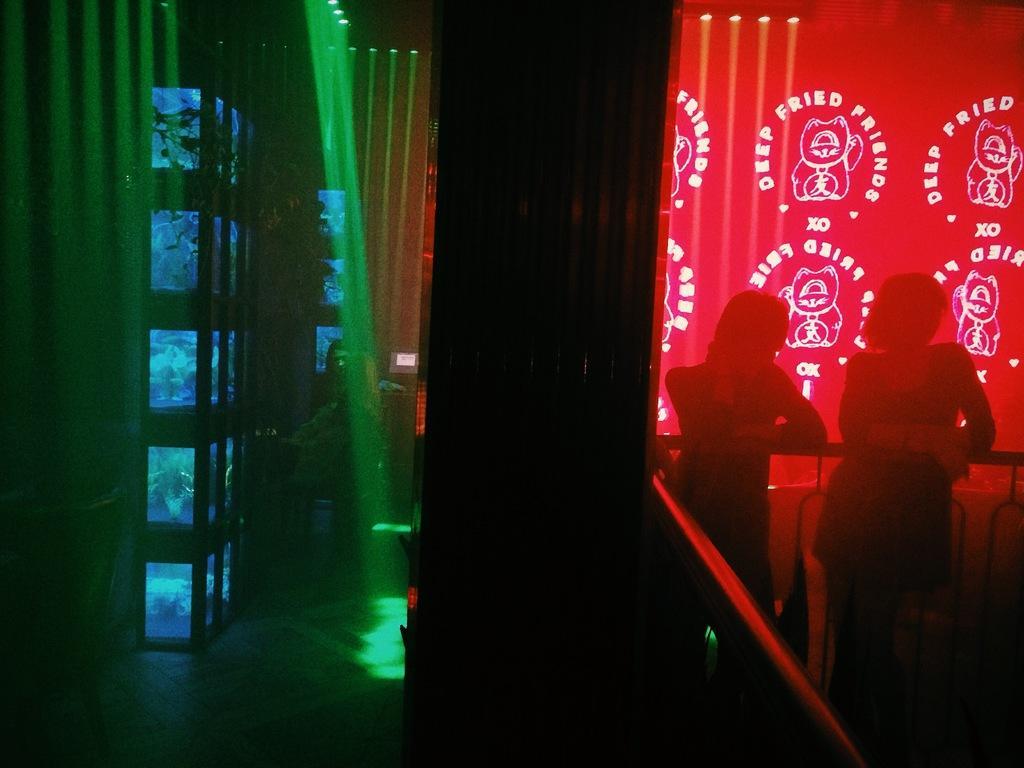How would you summarize this image in a sentence or two? On the right side of the image there are two people standing behind the railing. Behind them there is a wall with images and something is written on them. And also there are lights. Beside them there is a pillar. On the left side of the image there is a wall with screens and lights. And also there are few people in the background. 